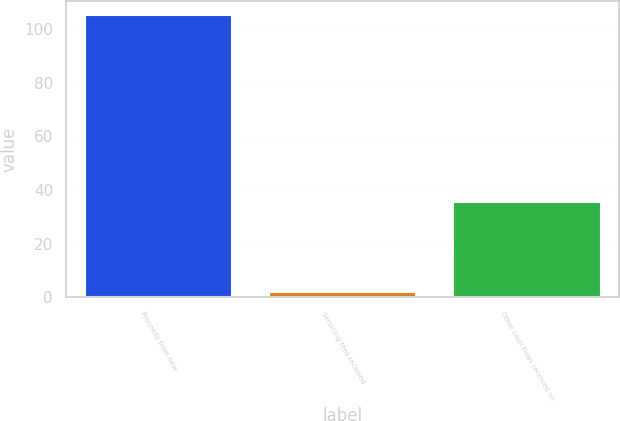Convert chart to OTSL. <chart><loc_0><loc_0><loc_500><loc_500><bar_chart><fcel>Proceeds from new<fcel>Servicing fees received<fcel>Other cash flows received on<nl><fcel>105.2<fcel>1.9<fcel>35.7<nl></chart> 